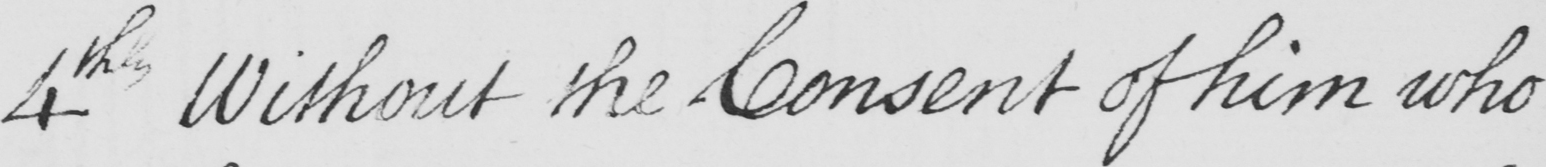What is written in this line of handwriting? 4th Without the Consent of him who 